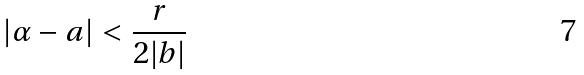Convert formula to latex. <formula><loc_0><loc_0><loc_500><loc_500>| \alpha - a | < \frac { r } { 2 | b | }</formula> 